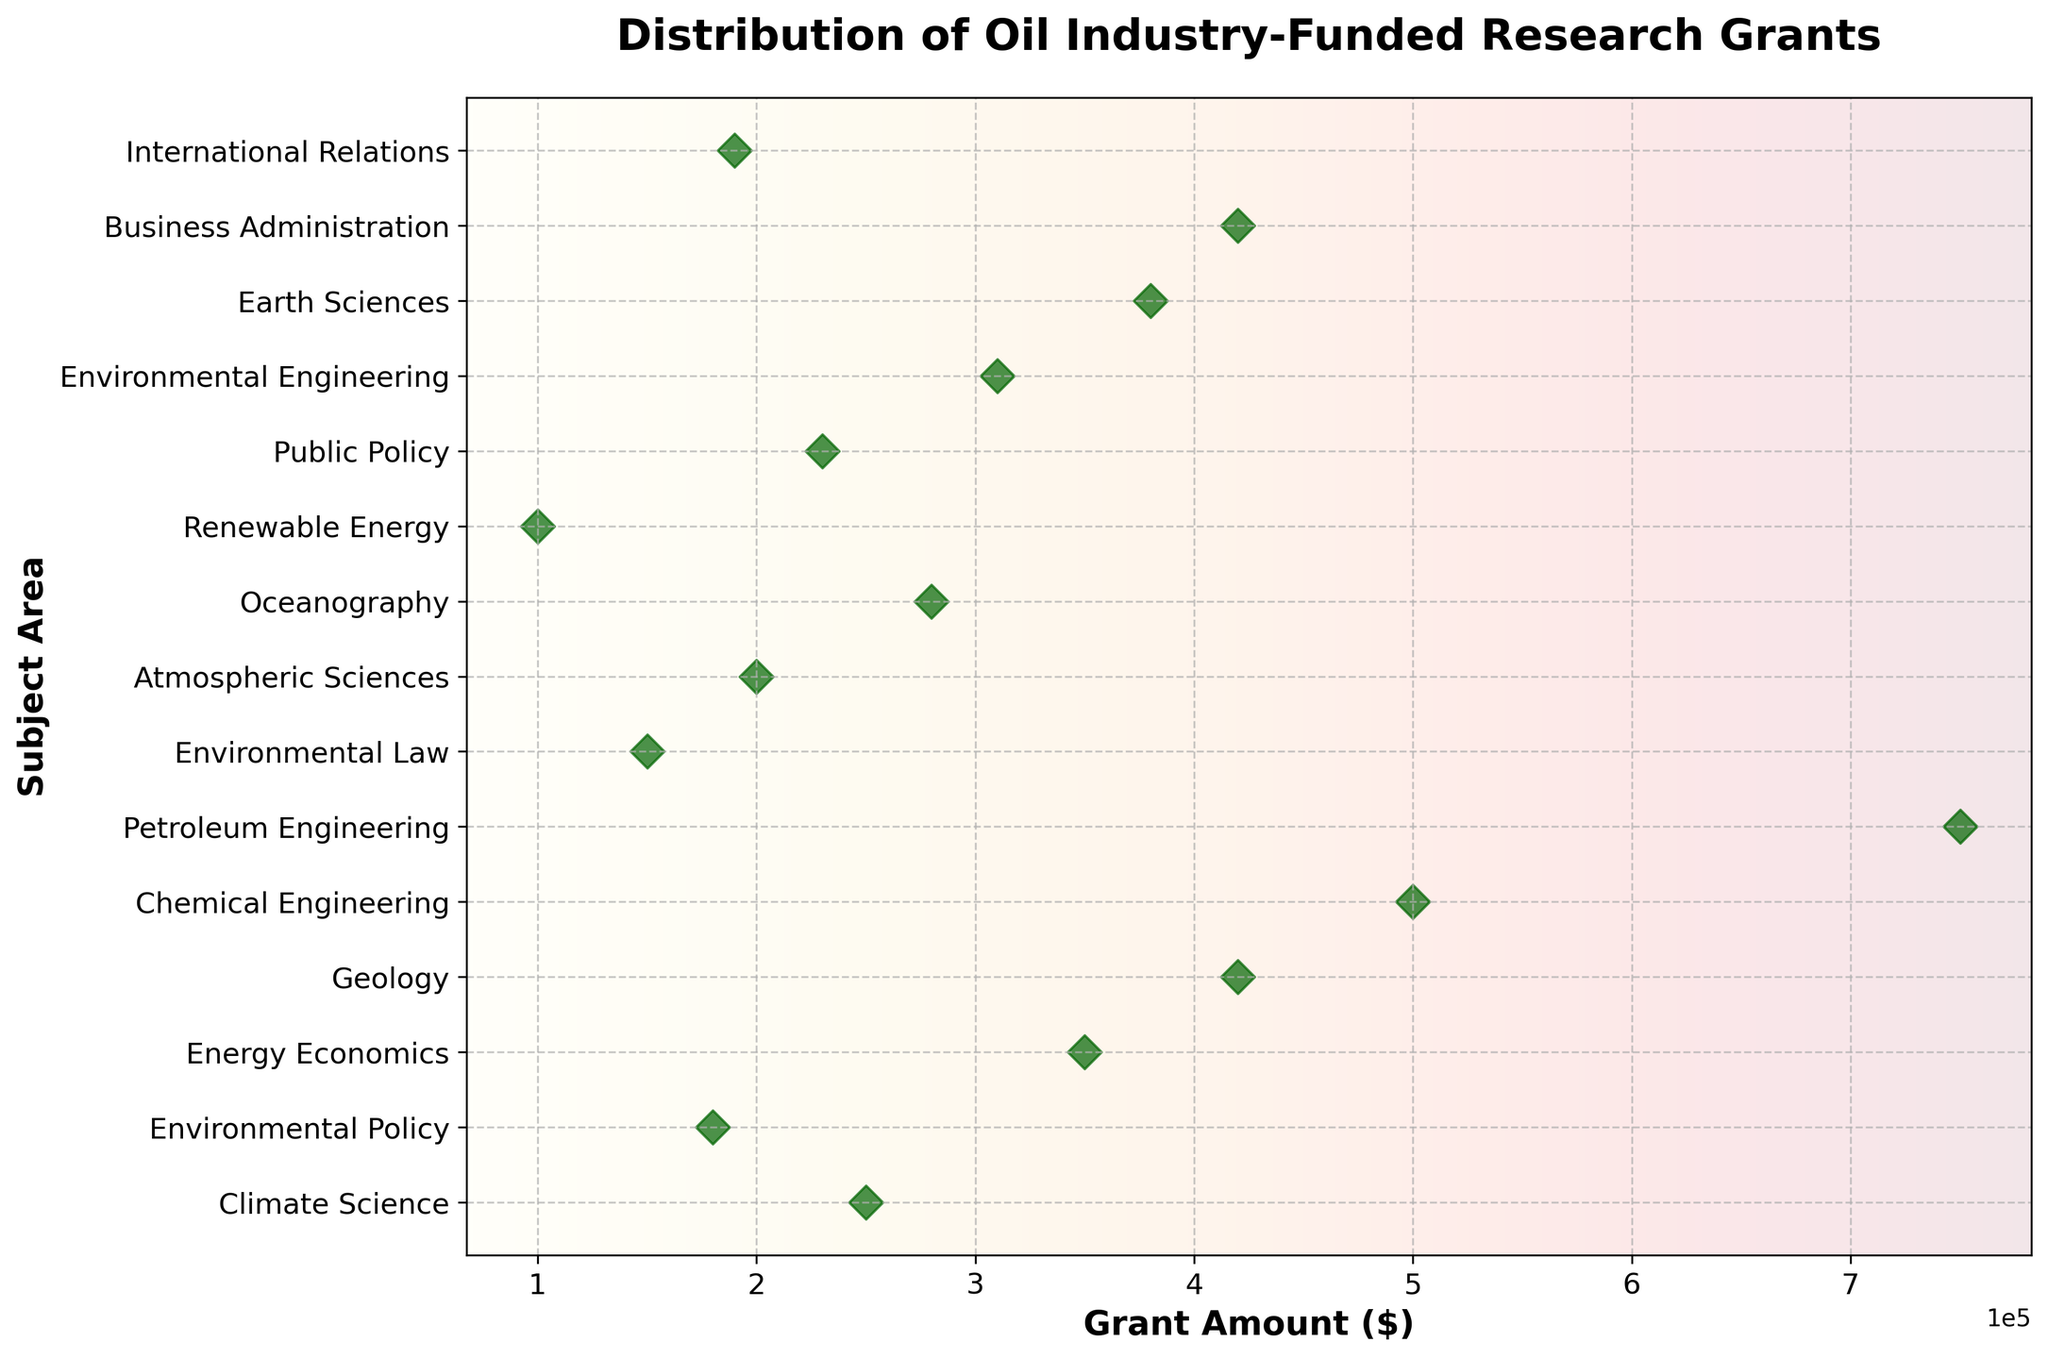What is the title of the plot? The title of the plot is displayed at the top of the figure, which reads 'Distribution of Oil Industry-Funded Research Grants'.
Answer: 'Distribution of Oil Industry-Funded Research Grants' Which subject area received the highest grant amount? By looking at the highest point on the x-axis, you observe that 'Petroleum Engineering' received the largest grant amount, which is $750,000.
Answer: Petroleum Engineering How much grant did the 'Environmental Policy' area receive? Find 'Environmental Policy' on the y-axis, and observe the corresponding x-value, which shows the grant amount as $180,000.
Answer: $180,000 What subject area received a grant amount of $150,000? You find the point corresponding to $150,000 on the x-axis and trace it to the y-axis to see that it aligns with 'Environmental Law'.
Answer: Environmental Law Which subject areas received more than $400,000 in grant amounts? Look at the dots to the right of the $400,000 mark on the x-axis. The corresponding subjects are 'Geology', 'Chemical Engineering', 'Petroleum Engineering', and 'Business Administration'.
Answer: Geology, Chemical Engineering, Petroleum Engineering, Business Administration What is the total grant amount for 'Climate Science' and 'Oceanography'? Locate the grant amounts for 'Climate Science' ($250,000) and 'Oceanography' ($280,000). Add them together to get a total of $250,000 + $280,000 = $530,000.
Answer: $530,000 Which subject area(s) received the smallest grant amount? Identify the smallest point on the x-axis, which is $100,000, and find the corresponding subject area, which is 'Renewable Energy'.
Answer: Renewable Energy Compare the grant amounts for 'Earth Sciences' and 'Energy Economics'. Which one is higher, and by how much? 'Earth Sciences' received $380,000, and 'Energy Economics' received $350,000. The difference is $380,000 - $350,000 = $30,000. Therefore, 'Earth Sciences' received $30,000 more than 'Energy Economics'.
Answer: Earth Sciences by $30,000 What's the average grant amount for 'Geology', 'Petroleum Engineering', and 'Chemical Engineering'? Add the grant amounts for 'Geology' ($420,000), 'Petroleum Engineering' ($750,000), and 'Chemical Engineering' ($500,000). The total is $1,670,000. Divide by 3 to get the average: $1,670,000 / 3 = $556,666.67
Answer: $556,666.67 How many subject areas received grants between $200,000 and $400,000? Count the points falling within the $200,000 to $400,000 range on the x-axis. The corresponding subjects are 'Atmospheric Sciences', 'Climate Science', 'Environmental Engineering', 'Earth Sciences', 'Oceanography', 'Public Policy', and 'Business Administration'. There are 7 subject areas in this range.
Answer: 7 